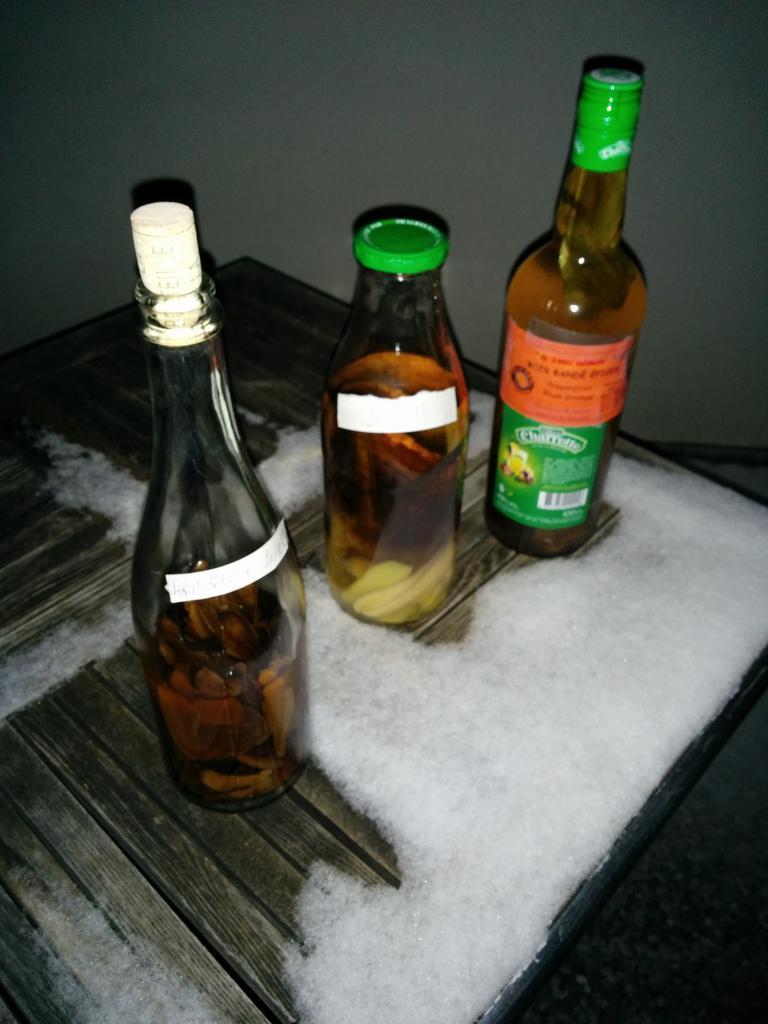How would you summarize this image in a sentence or two? It is a room , there is a wooden table and there are three bottles placed on the table, two of them are with green color cap and one is with white color cap sorry, it is a white color cork,in the background there is a wall. 